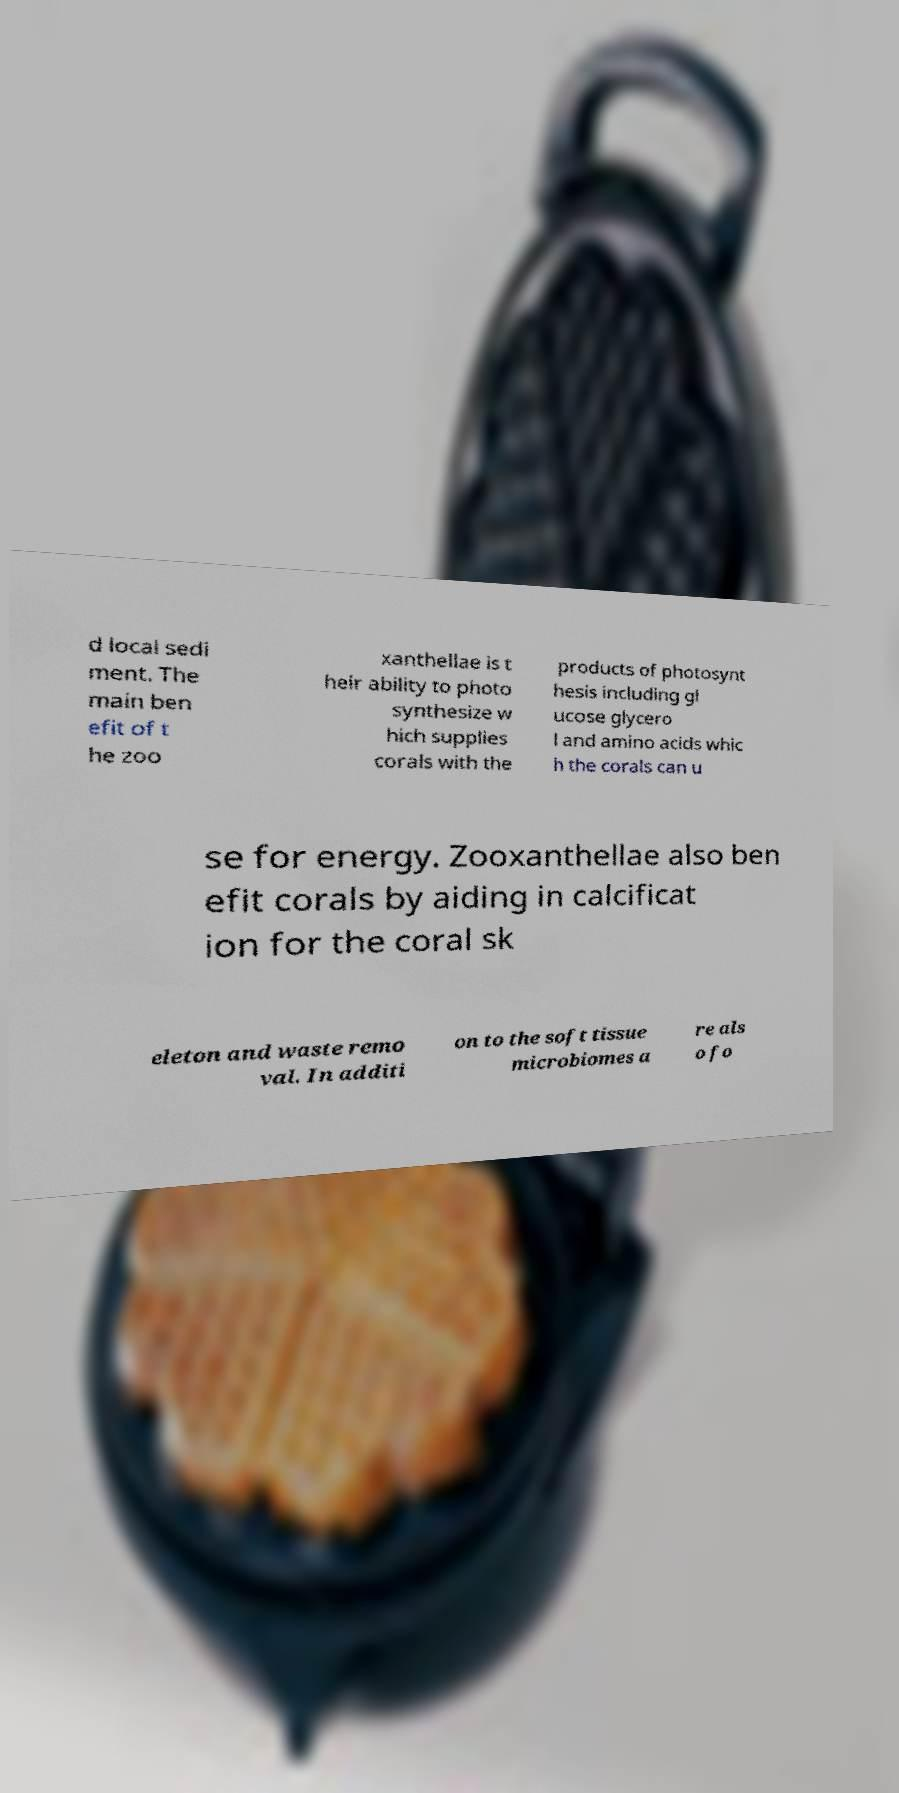Please read and relay the text visible in this image. What does it say? d local sedi ment. The main ben efit of t he zoo xanthellae is t heir ability to photo synthesize w hich supplies corals with the products of photosynt hesis including gl ucose glycero l and amino acids whic h the corals can u se for energy. Zooxanthellae also ben efit corals by aiding in calcificat ion for the coral sk eleton and waste remo val. In additi on to the soft tissue microbiomes a re als o fo 